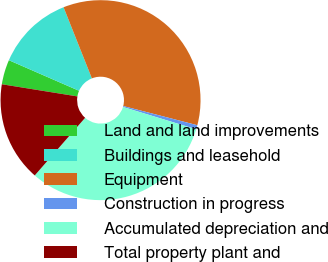Convert chart to OTSL. <chart><loc_0><loc_0><loc_500><loc_500><pie_chart><fcel>Land and land improvements<fcel>Buildings and leasehold<fcel>Equipment<fcel>Construction in progress<fcel>Accumulated depreciation and<fcel>Total property plant and<nl><fcel>4.0%<fcel>12.43%<fcel>35.07%<fcel>0.67%<fcel>31.73%<fcel>16.11%<nl></chart> 